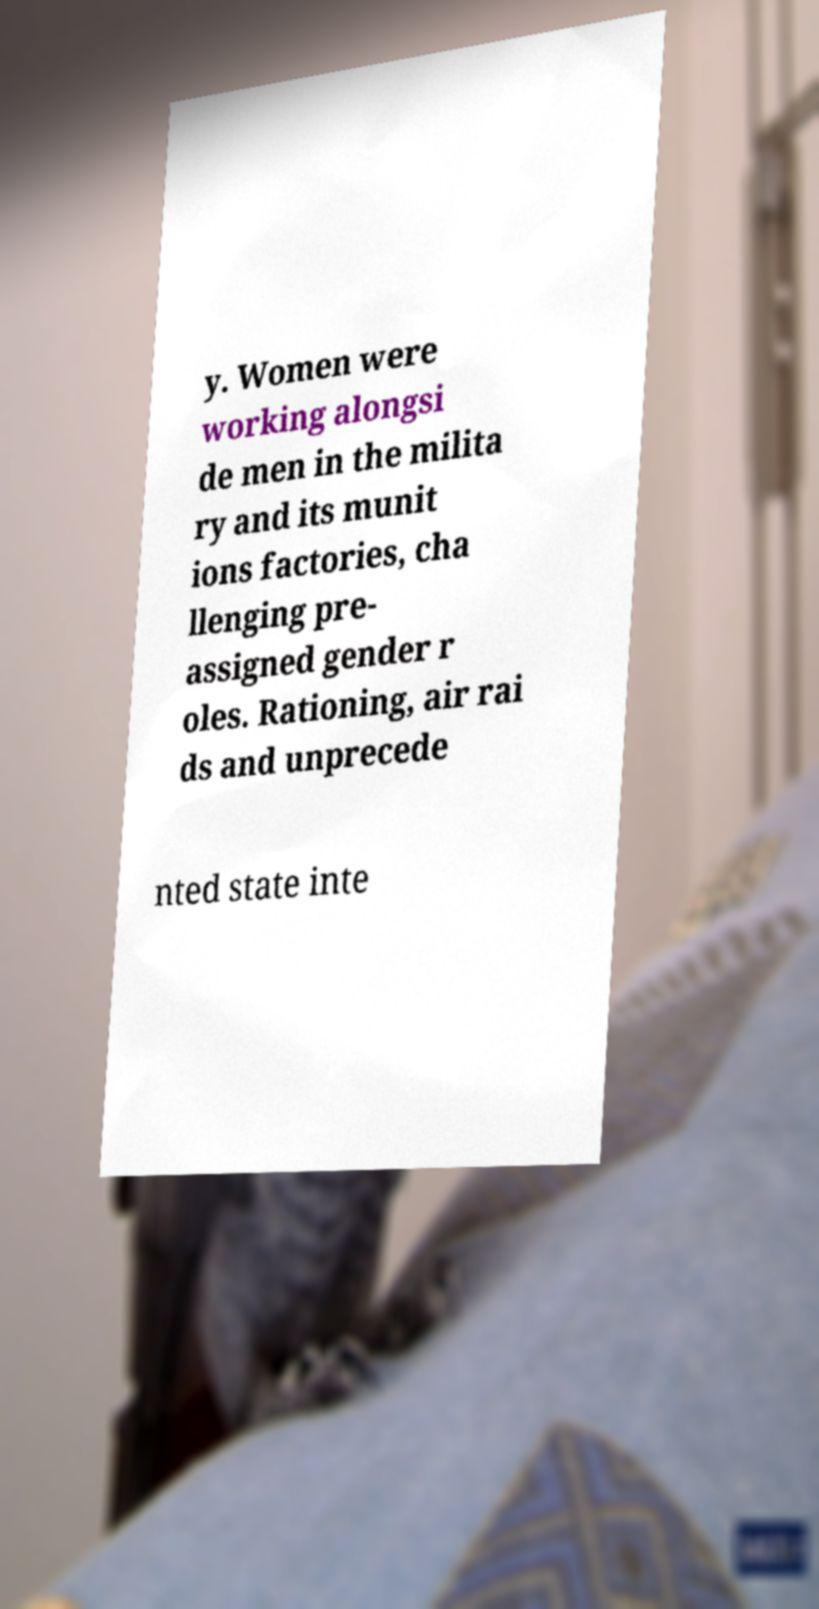Can you read and provide the text displayed in the image?This photo seems to have some interesting text. Can you extract and type it out for me? y. Women were working alongsi de men in the milita ry and its munit ions factories, cha llenging pre- assigned gender r oles. Rationing, air rai ds and unprecede nted state inte 